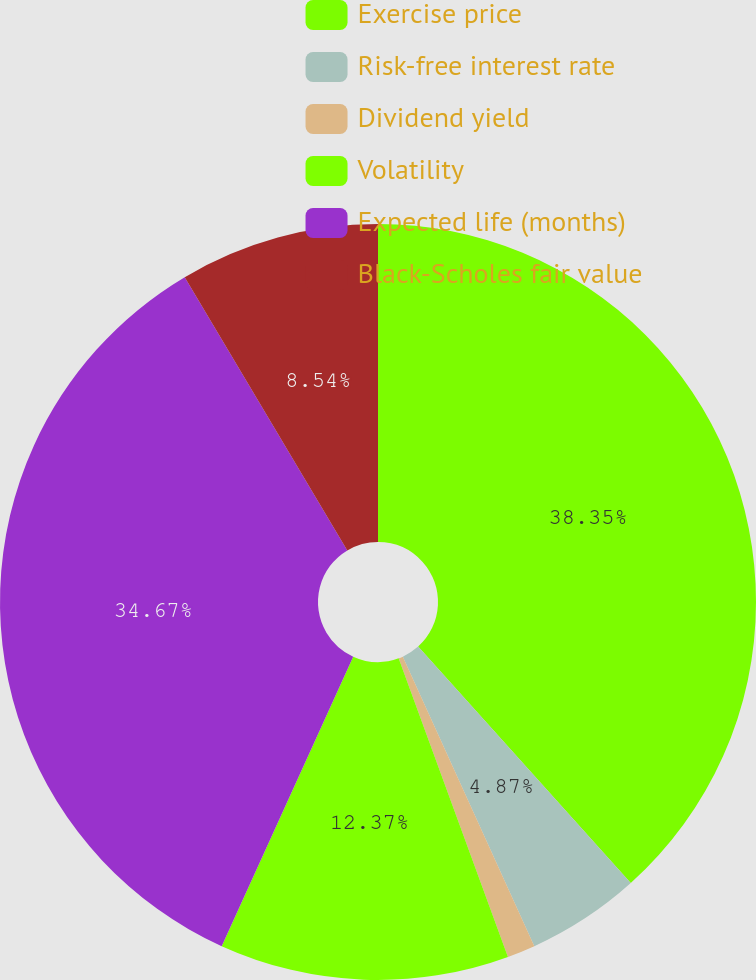Convert chart to OTSL. <chart><loc_0><loc_0><loc_500><loc_500><pie_chart><fcel>Exercise price<fcel>Risk-free interest rate<fcel>Dividend yield<fcel>Volatility<fcel>Expected life (months)<fcel>Black-Scholes fair value<nl><fcel>38.34%<fcel>4.87%<fcel>1.2%<fcel>12.37%<fcel>34.67%<fcel>8.54%<nl></chart> 